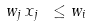Convert formula to latex. <formula><loc_0><loc_0><loc_500><loc_500>w _ { j } \, x _ { j } \ \leq w _ { i }</formula> 